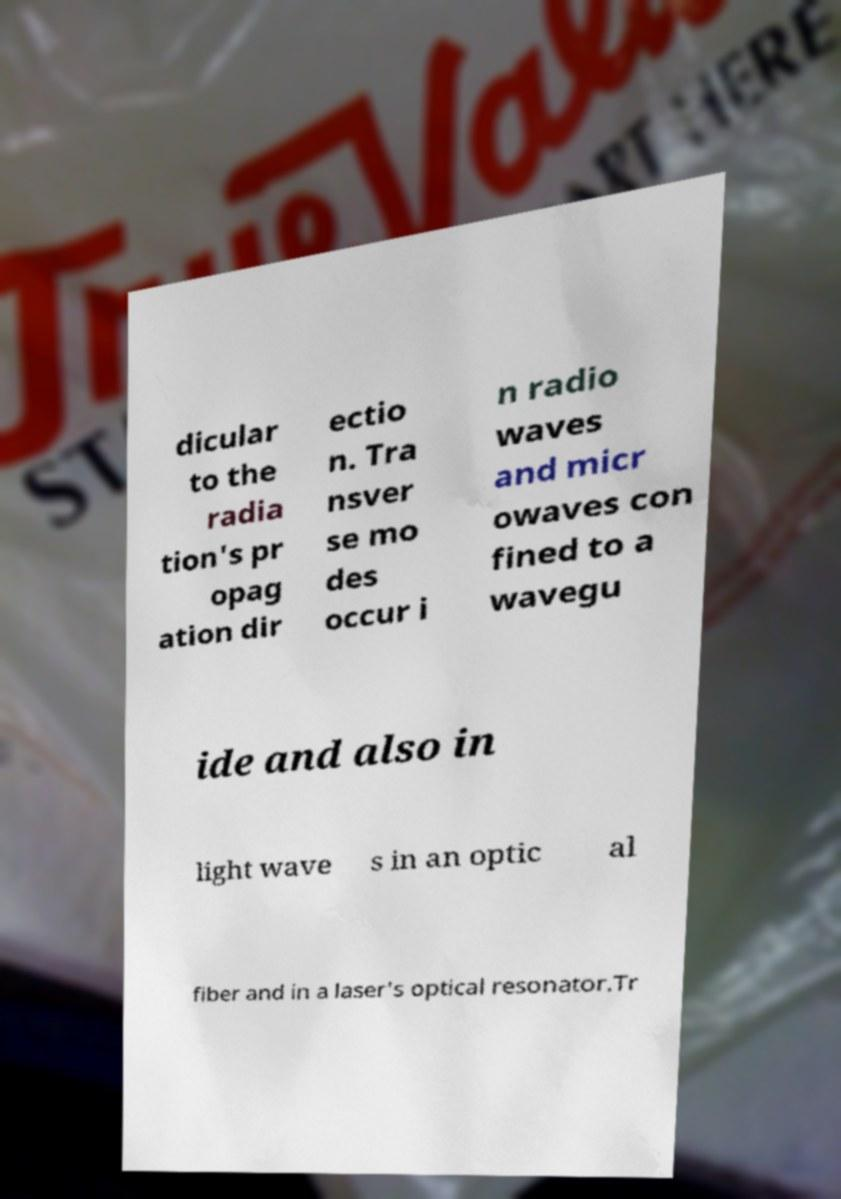There's text embedded in this image that I need extracted. Can you transcribe it verbatim? dicular to the radia tion's pr opag ation dir ectio n. Tra nsver se mo des occur i n radio waves and micr owaves con fined to a wavegu ide and also in light wave s in an optic al fiber and in a laser's optical resonator.Tr 